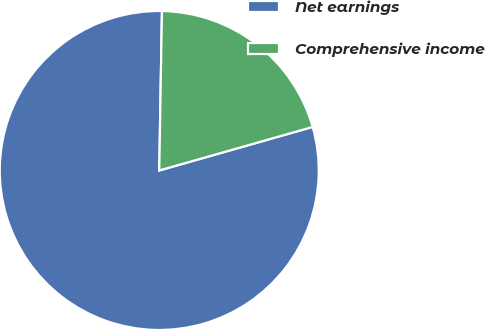<chart> <loc_0><loc_0><loc_500><loc_500><pie_chart><fcel>Net earnings<fcel>Comprehensive income<nl><fcel>79.67%<fcel>20.33%<nl></chart> 